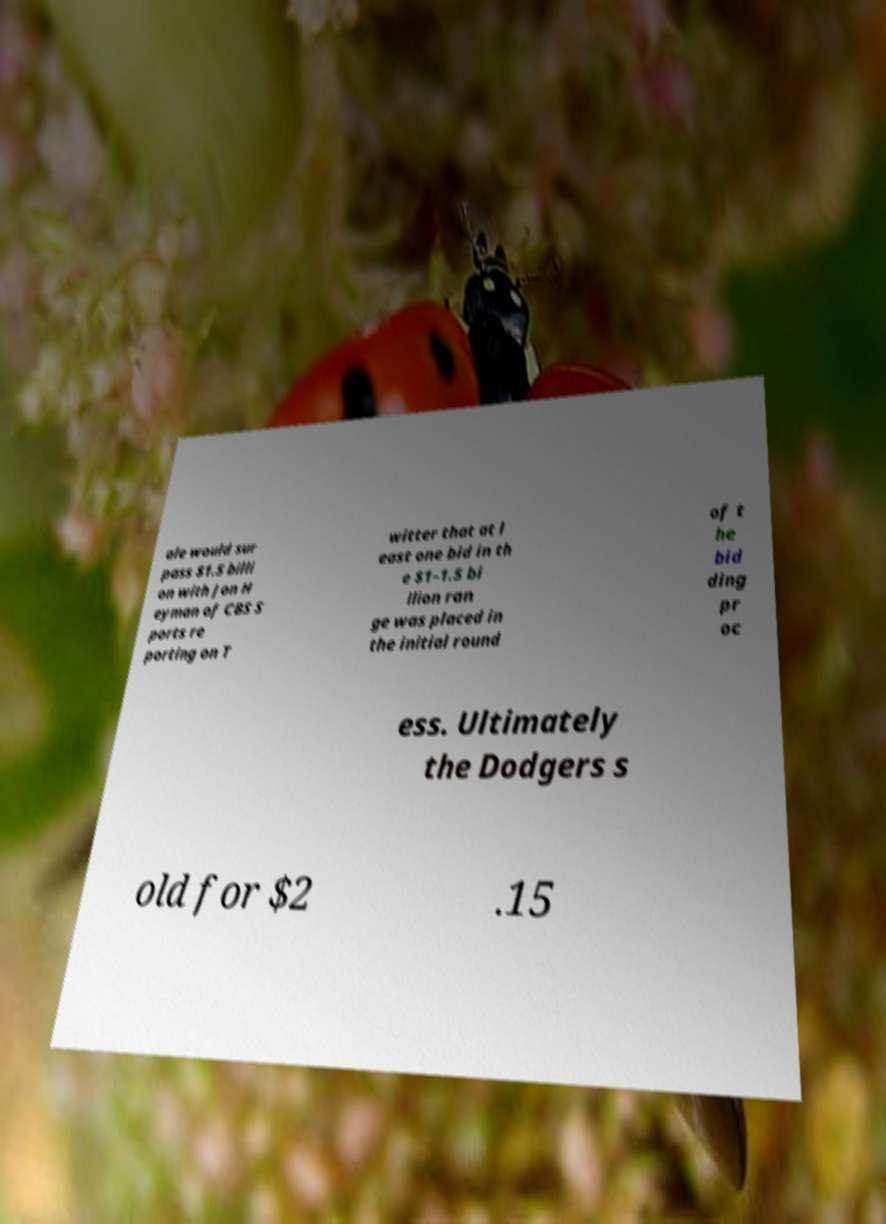Can you accurately transcribe the text from the provided image for me? ale would sur pass $1.5 billi on with Jon H eyman of CBS S ports re porting on T witter that at l east one bid in th e $1–1.5 bi llion ran ge was placed in the initial round of t he bid ding pr oc ess. Ultimately the Dodgers s old for $2 .15 